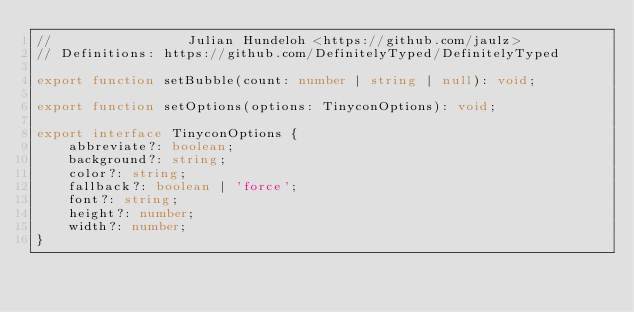Convert code to text. <code><loc_0><loc_0><loc_500><loc_500><_TypeScript_>//                 Julian Hundeloh <https://github.com/jaulz>
// Definitions: https://github.com/DefinitelyTyped/DefinitelyTyped

export function setBubble(count: number | string | null): void;

export function setOptions(options: TinyconOptions): void;

export interface TinyconOptions {
    abbreviate?: boolean;
    background?: string;
    color?: string;
    fallback?: boolean | 'force';
    font?: string;
    height?: number;
    width?: number;
}
</code> 